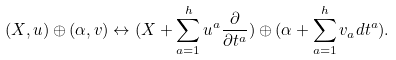<formula> <loc_0><loc_0><loc_500><loc_500>( X , u ) \oplus ( \alpha , v ) \leftrightarrow ( X + \sum _ { a = 1 } ^ { h } u ^ { a } \frac { \partial } { \partial t ^ { a } } ) \oplus ( \alpha + \sum _ { a = 1 } ^ { h } v _ { a } d t ^ { a } ) .</formula> 